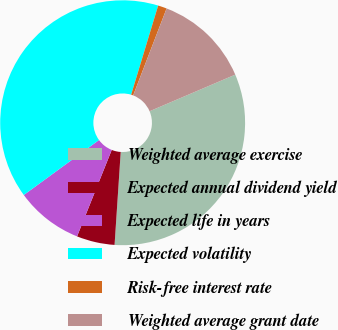Convert chart. <chart><loc_0><loc_0><loc_500><loc_500><pie_chart><fcel>Weighted average exercise<fcel>Expected annual dividend yield<fcel>Expected life in years<fcel>Expected volatility<fcel>Risk-free interest rate<fcel>Weighted average grant date<nl><fcel>32.48%<fcel>5.02%<fcel>8.88%<fcel>39.73%<fcel>1.16%<fcel>12.73%<nl></chart> 